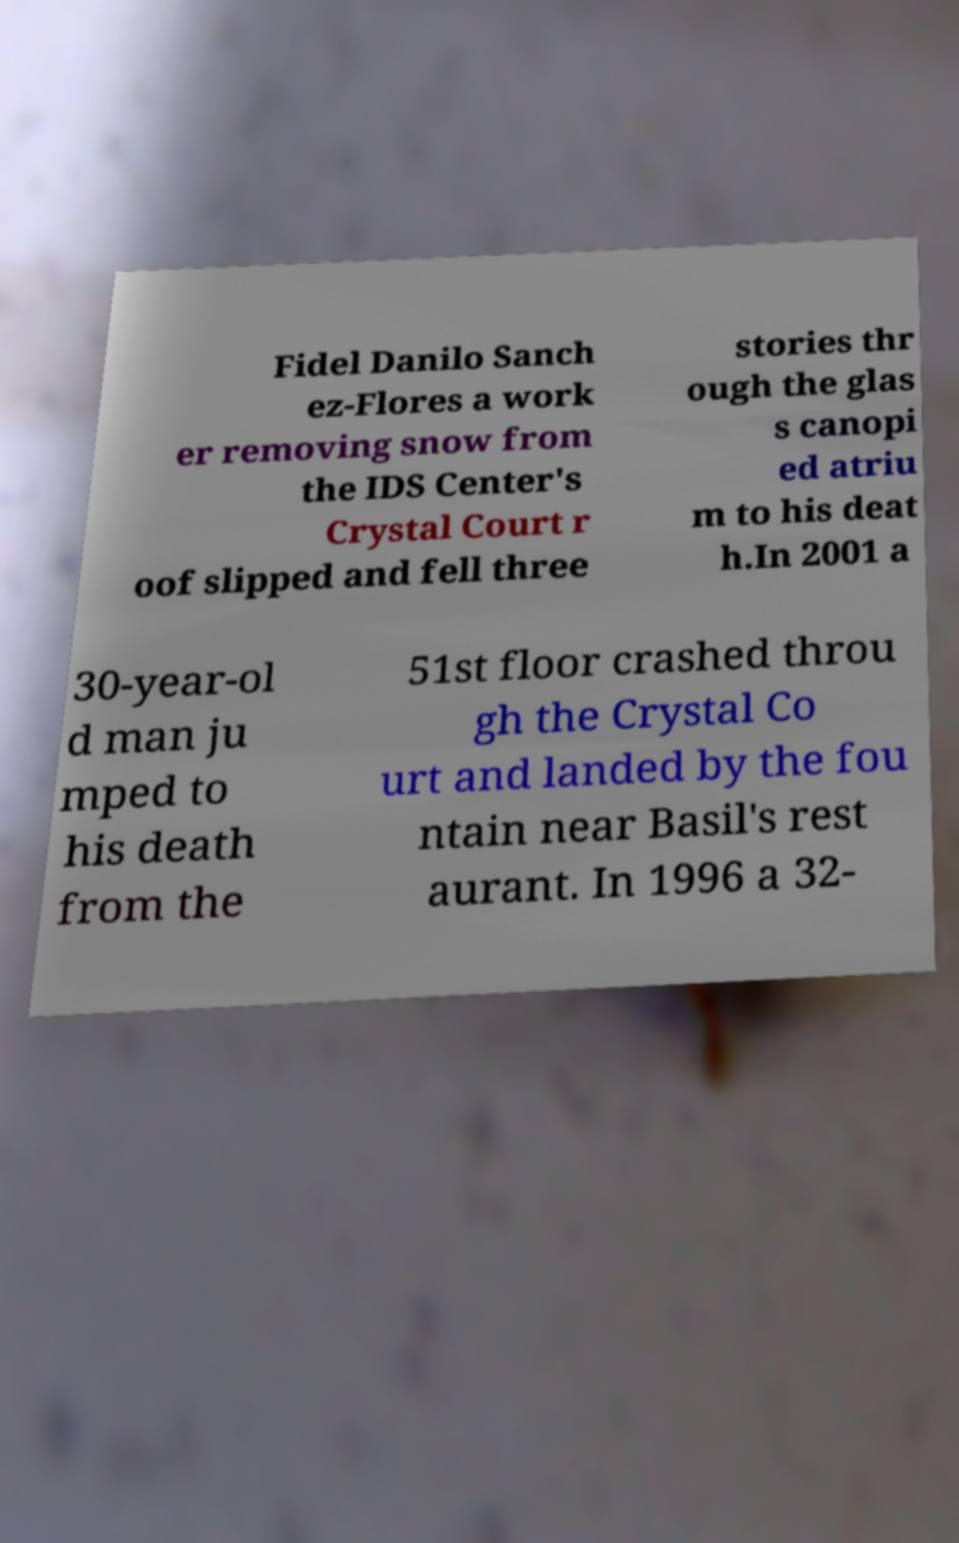Please identify and transcribe the text found in this image. Fidel Danilo Sanch ez-Flores a work er removing snow from the IDS Center's Crystal Court r oof slipped and fell three stories thr ough the glas s canopi ed atriu m to his deat h.In 2001 a 30-year-ol d man ju mped to his death from the 51st floor crashed throu gh the Crystal Co urt and landed by the fou ntain near Basil's rest aurant. In 1996 a 32- 